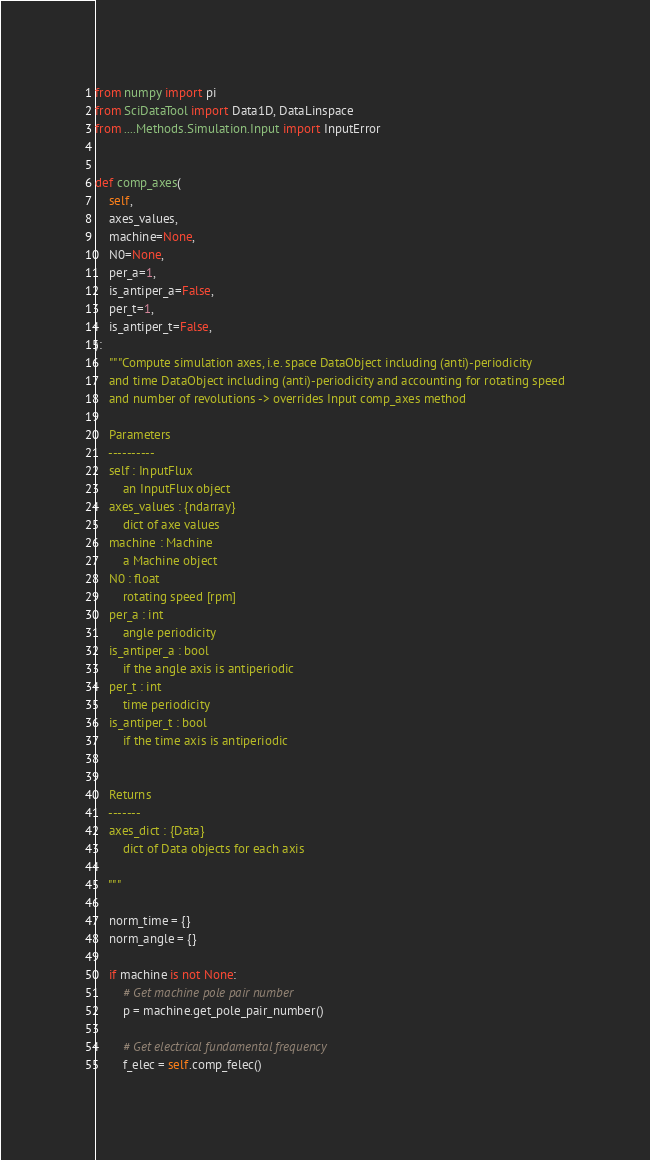Convert code to text. <code><loc_0><loc_0><loc_500><loc_500><_Python_>from numpy import pi
from SciDataTool import Data1D, DataLinspace
from ....Methods.Simulation.Input import InputError


def comp_axes(
    self,
    axes_values,
    machine=None,
    N0=None,
    per_a=1,
    is_antiper_a=False,
    per_t=1,
    is_antiper_t=False,
):
    """Compute simulation axes, i.e. space DataObject including (anti)-periodicity
    and time DataObject including (anti)-periodicity and accounting for rotating speed
    and number of revolutions -> overrides Input comp_axes method

    Parameters
    ----------
    self : InputFlux
        an InputFlux object
    axes_values : {ndarray}
        dict of axe values
    machine : Machine
        a Machine object
    N0 : float
        rotating speed [rpm]
    per_a : int
        angle periodicity
    is_antiper_a : bool
        if the angle axis is antiperiodic
    per_t : int
        time periodicity
    is_antiper_t : bool
        if the time axis is antiperiodic


    Returns
    -------
    axes_dict : {Data}
        dict of Data objects for each axis

    """

    norm_time = {}
    norm_angle = {}

    if machine is not None:
        # Get machine pole pair number
        p = machine.get_pole_pair_number()

        # Get electrical fundamental frequency
        f_elec = self.comp_felec()
</code> 